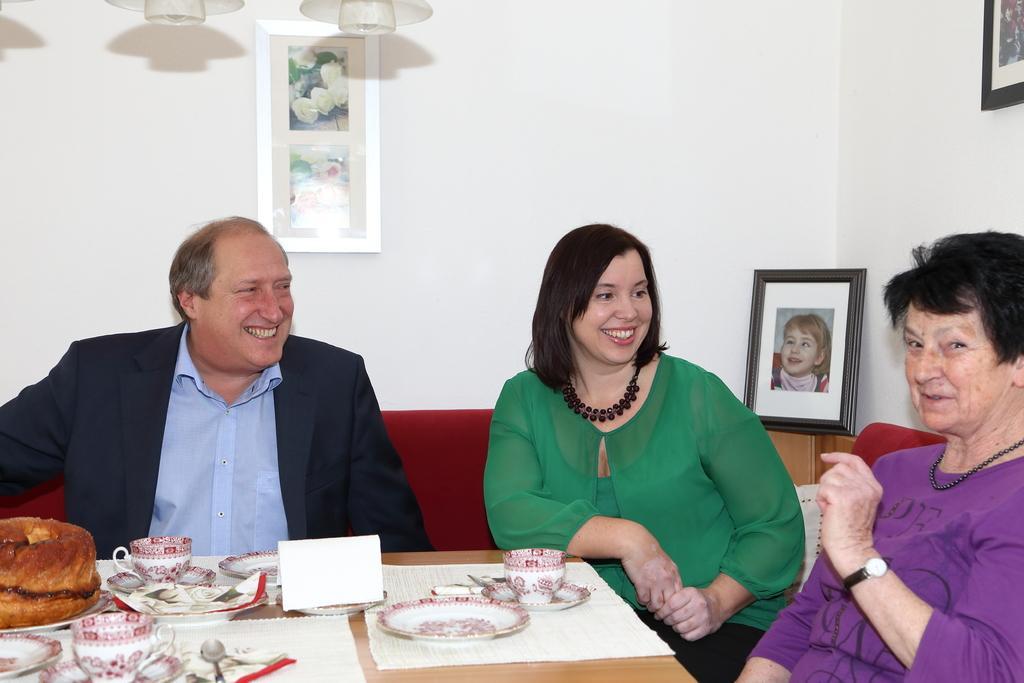Could you give a brief overview of what you see in this image? Here we can see three persons are sitting on the sofa. This is table. On the table there are plates, cups, spoons, and some food. On the background there is a wall and these are the frames. 